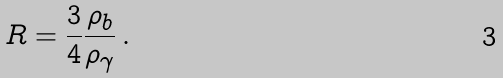Convert formula to latex. <formula><loc_0><loc_0><loc_500><loc_500>R = \frac { 3 } { 4 } \frac { \rho _ { b } } { \rho _ { \gamma } } \, .</formula> 